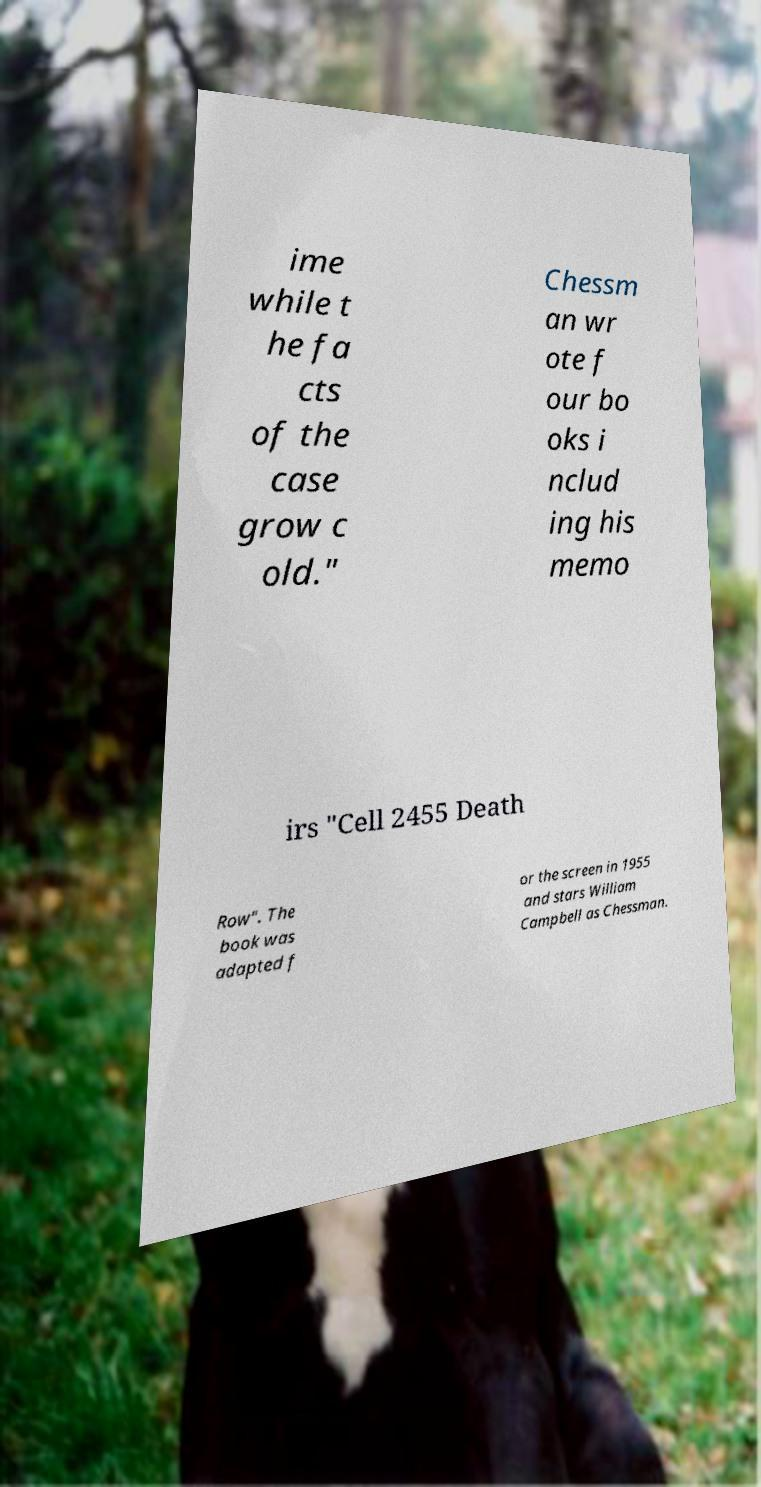Please read and relay the text visible in this image. What does it say? ime while t he fa cts of the case grow c old." Chessm an wr ote f our bo oks i nclud ing his memo irs "Cell 2455 Death Row". The book was adapted f or the screen in 1955 and stars William Campbell as Chessman. 